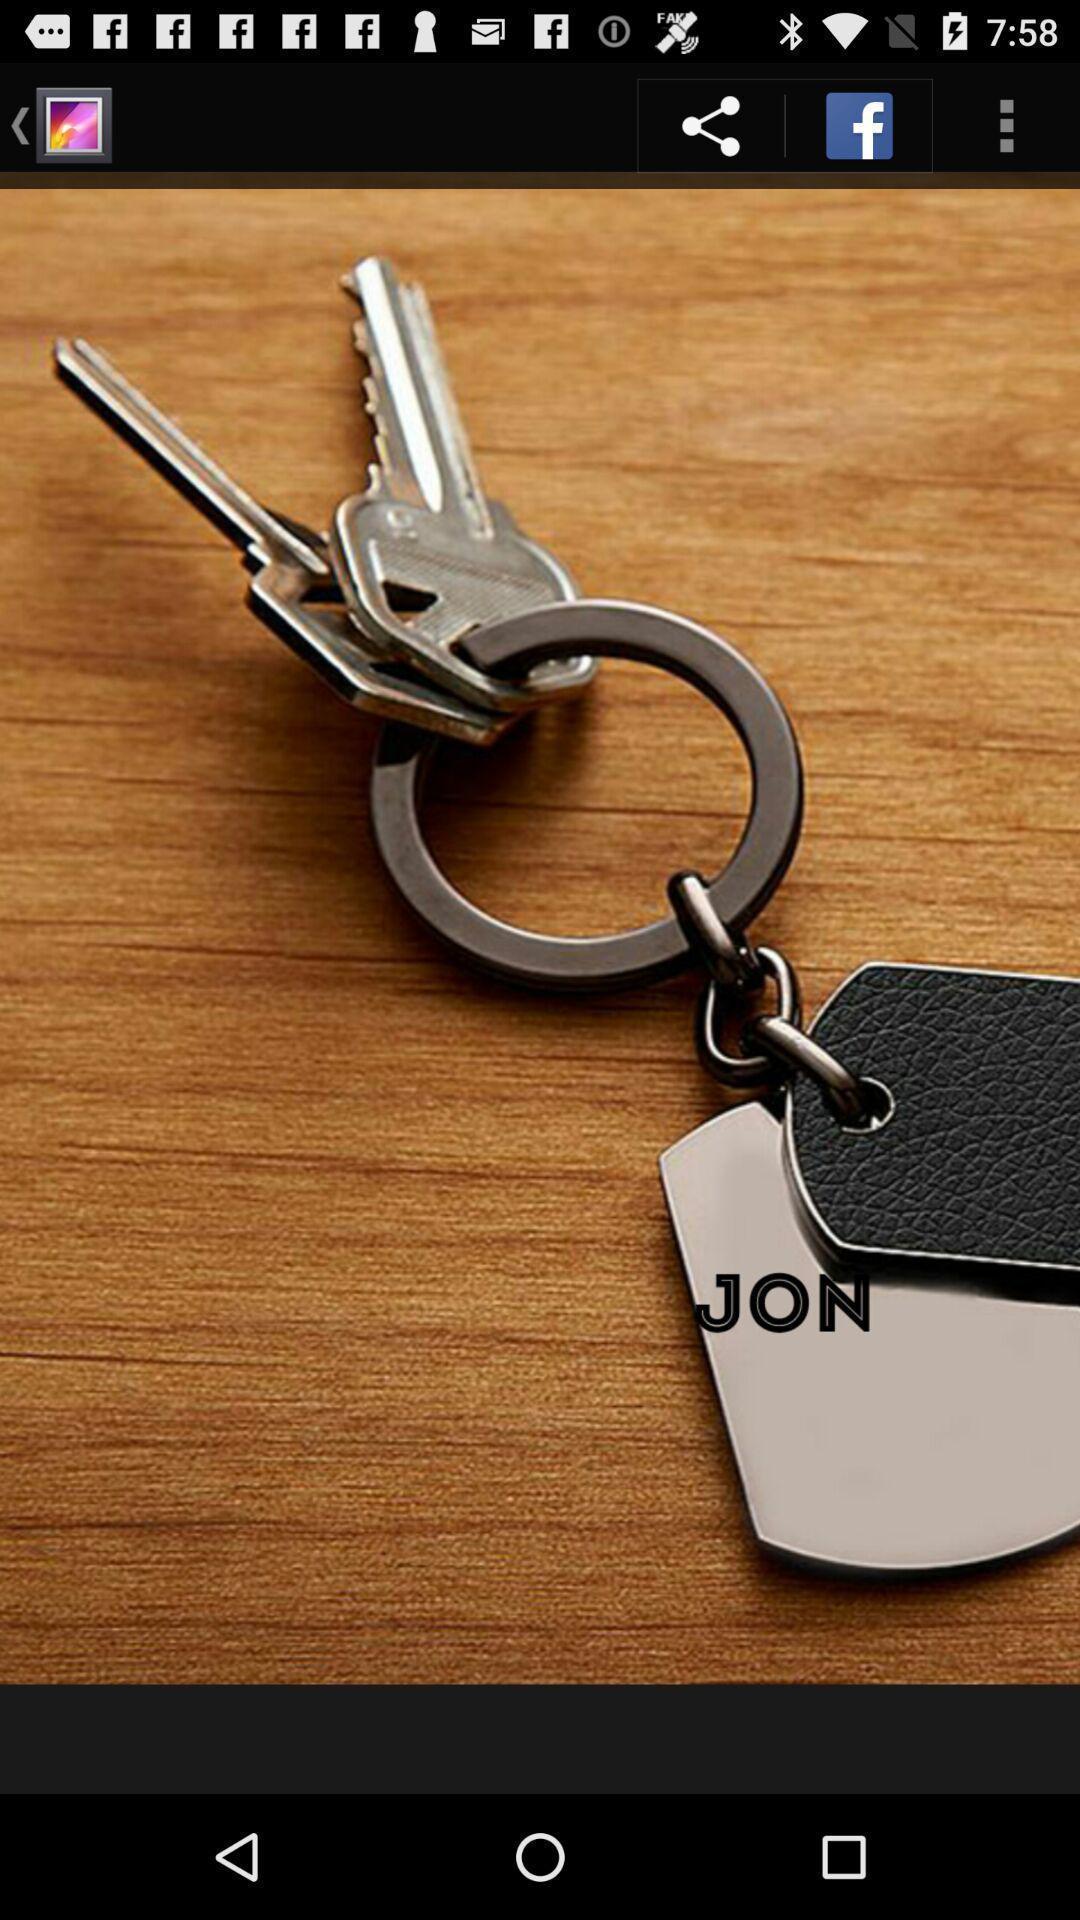Explain what's happening in this screen capture. Screen shows a picture from a gallery. 